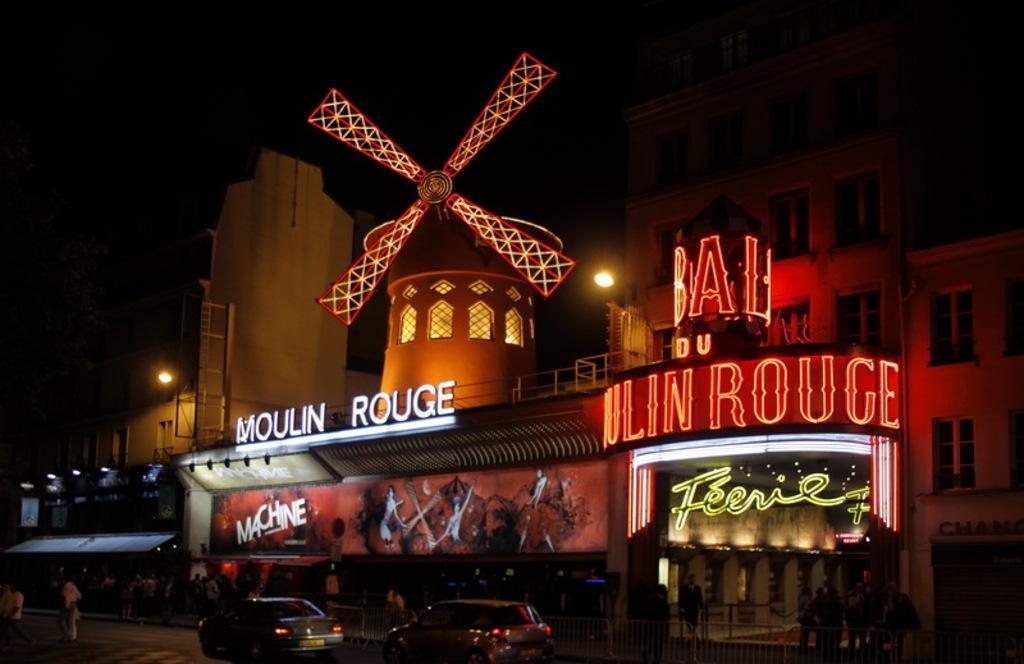Describe this image in one or two sentences. In this picture I can see the buildings. At the bottom there are two cars which are parked near to the stairs. Beside that I can see many people were standing near to the wall. At the top I can see the darkness. 